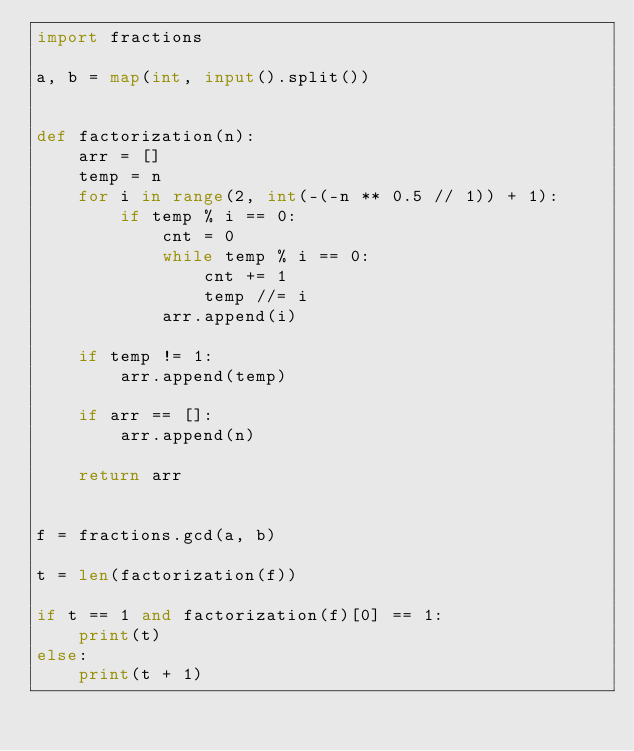<code> <loc_0><loc_0><loc_500><loc_500><_Python_>import fractions

a, b = map(int, input().split())


def factorization(n):
    arr = []
    temp = n
    for i in range(2, int(-(-n ** 0.5 // 1)) + 1):
        if temp % i == 0:
            cnt = 0
            while temp % i == 0:
                cnt += 1
                temp //= i
            arr.append(i)

    if temp != 1:
        arr.append(temp)

    if arr == []:
        arr.append(n)

    return arr


f = fractions.gcd(a, b)

t = len(factorization(f))

if t == 1 and factorization(f)[0] == 1:
    print(t)
else:
    print(t + 1)
</code> 